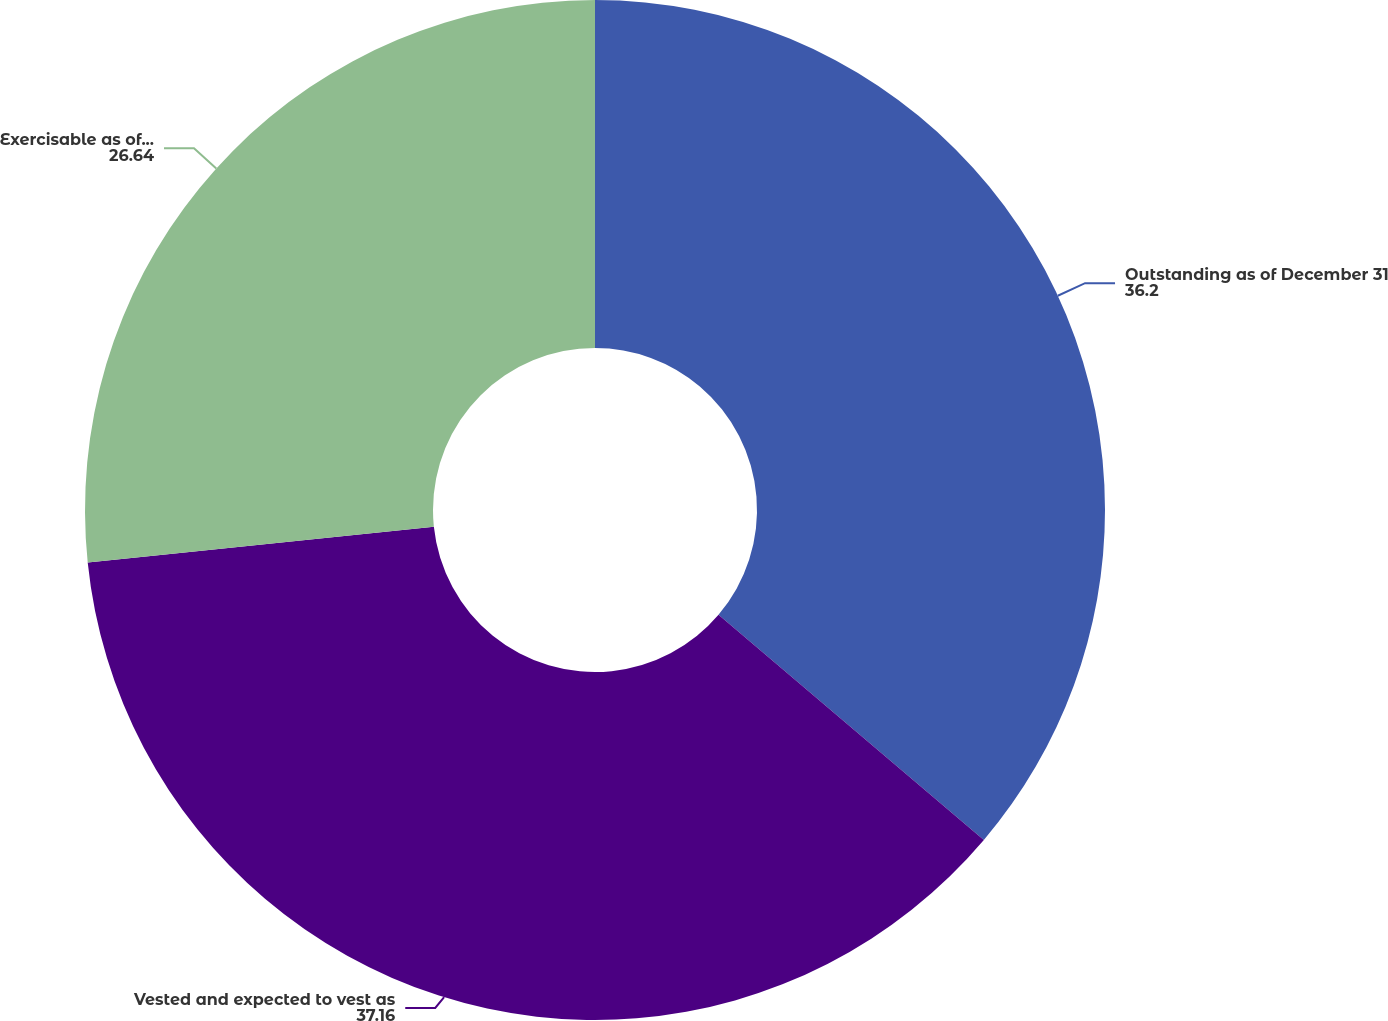Convert chart. <chart><loc_0><loc_0><loc_500><loc_500><pie_chart><fcel>Outstanding as of December 31<fcel>Vested and expected to vest as<fcel>Exercisable as of December 31<nl><fcel>36.2%<fcel>37.16%<fcel>26.64%<nl></chart> 